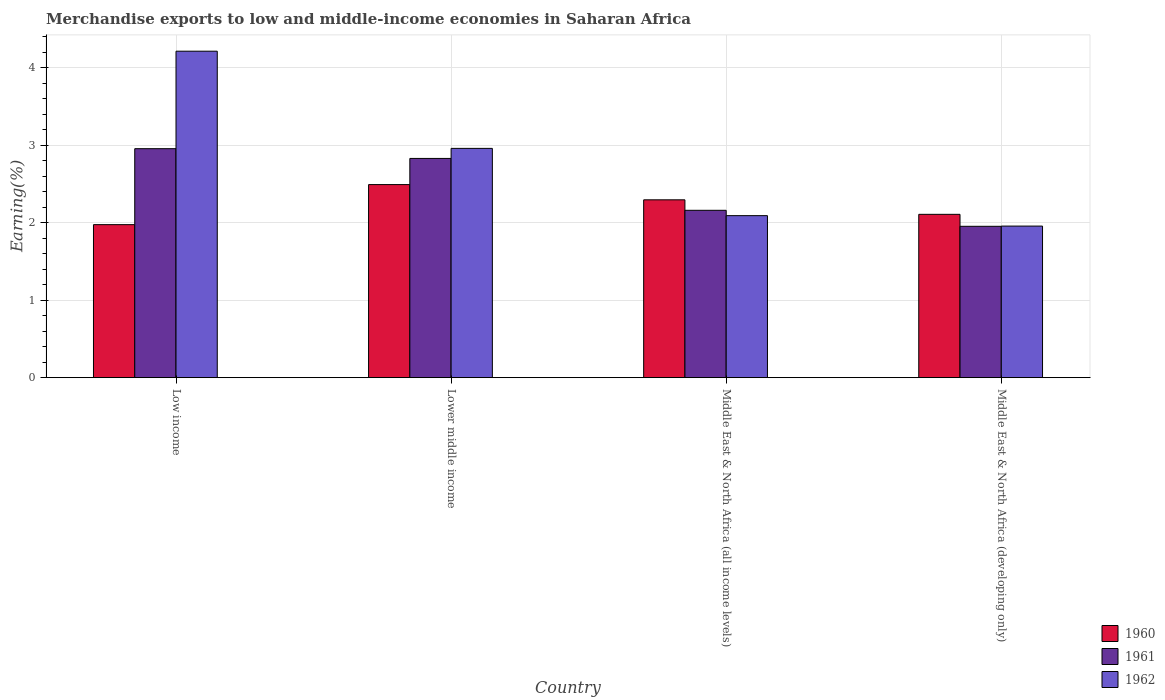How many different coloured bars are there?
Your answer should be very brief. 3. How many groups of bars are there?
Ensure brevity in your answer.  4. Are the number of bars on each tick of the X-axis equal?
Offer a terse response. Yes. What is the label of the 4th group of bars from the left?
Provide a succinct answer. Middle East & North Africa (developing only). What is the percentage of amount earned from merchandise exports in 1962 in Lower middle income?
Your answer should be compact. 2.96. Across all countries, what is the maximum percentage of amount earned from merchandise exports in 1962?
Your answer should be compact. 4.21. Across all countries, what is the minimum percentage of amount earned from merchandise exports in 1961?
Your answer should be compact. 1.95. In which country was the percentage of amount earned from merchandise exports in 1961 maximum?
Ensure brevity in your answer.  Low income. What is the total percentage of amount earned from merchandise exports in 1960 in the graph?
Provide a succinct answer. 8.87. What is the difference between the percentage of amount earned from merchandise exports in 1960 in Middle East & North Africa (all income levels) and that in Middle East & North Africa (developing only)?
Provide a succinct answer. 0.19. What is the difference between the percentage of amount earned from merchandise exports in 1961 in Low income and the percentage of amount earned from merchandise exports in 1962 in Middle East & North Africa (all income levels)?
Give a very brief answer. 0.86. What is the average percentage of amount earned from merchandise exports in 1960 per country?
Keep it short and to the point. 2.22. What is the difference between the percentage of amount earned from merchandise exports of/in 1960 and percentage of amount earned from merchandise exports of/in 1961 in Low income?
Keep it short and to the point. -0.98. What is the ratio of the percentage of amount earned from merchandise exports in 1962 in Lower middle income to that in Middle East & North Africa (all income levels)?
Offer a very short reply. 1.42. Is the difference between the percentage of amount earned from merchandise exports in 1960 in Lower middle income and Middle East & North Africa (all income levels) greater than the difference between the percentage of amount earned from merchandise exports in 1961 in Lower middle income and Middle East & North Africa (all income levels)?
Offer a very short reply. No. What is the difference between the highest and the second highest percentage of amount earned from merchandise exports in 1960?
Ensure brevity in your answer.  -0.38. What is the difference between the highest and the lowest percentage of amount earned from merchandise exports in 1962?
Make the answer very short. 2.26. Is the sum of the percentage of amount earned from merchandise exports in 1960 in Middle East & North Africa (all income levels) and Middle East & North Africa (developing only) greater than the maximum percentage of amount earned from merchandise exports in 1961 across all countries?
Your response must be concise. Yes. What does the 3rd bar from the left in Low income represents?
Provide a succinct answer. 1962. Are all the bars in the graph horizontal?
Your answer should be very brief. No. What is the difference between two consecutive major ticks on the Y-axis?
Offer a very short reply. 1. Are the values on the major ticks of Y-axis written in scientific E-notation?
Give a very brief answer. No. What is the title of the graph?
Your response must be concise. Merchandise exports to low and middle-income economies in Saharan Africa. Does "1995" appear as one of the legend labels in the graph?
Your response must be concise. No. What is the label or title of the X-axis?
Your answer should be very brief. Country. What is the label or title of the Y-axis?
Give a very brief answer. Earning(%). What is the Earning(%) of 1960 in Low income?
Offer a terse response. 1.97. What is the Earning(%) of 1961 in Low income?
Your answer should be very brief. 2.95. What is the Earning(%) in 1962 in Low income?
Give a very brief answer. 4.21. What is the Earning(%) of 1960 in Lower middle income?
Provide a succinct answer. 2.49. What is the Earning(%) in 1961 in Lower middle income?
Offer a terse response. 2.83. What is the Earning(%) in 1962 in Lower middle income?
Keep it short and to the point. 2.96. What is the Earning(%) of 1960 in Middle East & North Africa (all income levels)?
Your answer should be very brief. 2.29. What is the Earning(%) in 1961 in Middle East & North Africa (all income levels)?
Provide a succinct answer. 2.16. What is the Earning(%) in 1962 in Middle East & North Africa (all income levels)?
Offer a terse response. 2.09. What is the Earning(%) in 1960 in Middle East & North Africa (developing only)?
Keep it short and to the point. 2.11. What is the Earning(%) in 1961 in Middle East & North Africa (developing only)?
Make the answer very short. 1.95. What is the Earning(%) of 1962 in Middle East & North Africa (developing only)?
Keep it short and to the point. 1.96. Across all countries, what is the maximum Earning(%) of 1960?
Keep it short and to the point. 2.49. Across all countries, what is the maximum Earning(%) of 1961?
Your answer should be very brief. 2.95. Across all countries, what is the maximum Earning(%) of 1962?
Offer a terse response. 4.21. Across all countries, what is the minimum Earning(%) of 1960?
Ensure brevity in your answer.  1.97. Across all countries, what is the minimum Earning(%) of 1961?
Provide a succinct answer. 1.95. Across all countries, what is the minimum Earning(%) of 1962?
Offer a very short reply. 1.96. What is the total Earning(%) of 1960 in the graph?
Offer a terse response. 8.87. What is the total Earning(%) in 1961 in the graph?
Your response must be concise. 9.89. What is the total Earning(%) of 1962 in the graph?
Ensure brevity in your answer.  11.21. What is the difference between the Earning(%) in 1960 in Low income and that in Lower middle income?
Your answer should be compact. -0.52. What is the difference between the Earning(%) of 1961 in Low income and that in Lower middle income?
Make the answer very short. 0.13. What is the difference between the Earning(%) in 1962 in Low income and that in Lower middle income?
Your response must be concise. 1.25. What is the difference between the Earning(%) in 1960 in Low income and that in Middle East & North Africa (all income levels)?
Ensure brevity in your answer.  -0.32. What is the difference between the Earning(%) in 1961 in Low income and that in Middle East & North Africa (all income levels)?
Offer a terse response. 0.79. What is the difference between the Earning(%) in 1962 in Low income and that in Middle East & North Africa (all income levels)?
Ensure brevity in your answer.  2.12. What is the difference between the Earning(%) of 1960 in Low income and that in Middle East & North Africa (developing only)?
Make the answer very short. -0.13. What is the difference between the Earning(%) of 1961 in Low income and that in Middle East & North Africa (developing only)?
Keep it short and to the point. 1. What is the difference between the Earning(%) in 1962 in Low income and that in Middle East & North Africa (developing only)?
Provide a succinct answer. 2.26. What is the difference between the Earning(%) of 1960 in Lower middle income and that in Middle East & North Africa (all income levels)?
Provide a short and direct response. 0.2. What is the difference between the Earning(%) of 1961 in Lower middle income and that in Middle East & North Africa (all income levels)?
Your response must be concise. 0.67. What is the difference between the Earning(%) of 1962 in Lower middle income and that in Middle East & North Africa (all income levels)?
Ensure brevity in your answer.  0.87. What is the difference between the Earning(%) in 1960 in Lower middle income and that in Middle East & North Africa (developing only)?
Your answer should be compact. 0.38. What is the difference between the Earning(%) of 1961 in Lower middle income and that in Middle East & North Africa (developing only)?
Ensure brevity in your answer.  0.88. What is the difference between the Earning(%) of 1960 in Middle East & North Africa (all income levels) and that in Middle East & North Africa (developing only)?
Keep it short and to the point. 0.19. What is the difference between the Earning(%) of 1961 in Middle East & North Africa (all income levels) and that in Middle East & North Africa (developing only)?
Your answer should be very brief. 0.21. What is the difference between the Earning(%) in 1962 in Middle East & North Africa (all income levels) and that in Middle East & North Africa (developing only)?
Offer a terse response. 0.13. What is the difference between the Earning(%) in 1960 in Low income and the Earning(%) in 1961 in Lower middle income?
Ensure brevity in your answer.  -0.85. What is the difference between the Earning(%) in 1960 in Low income and the Earning(%) in 1962 in Lower middle income?
Provide a succinct answer. -0.98. What is the difference between the Earning(%) of 1961 in Low income and the Earning(%) of 1962 in Lower middle income?
Offer a very short reply. -0. What is the difference between the Earning(%) of 1960 in Low income and the Earning(%) of 1961 in Middle East & North Africa (all income levels)?
Give a very brief answer. -0.18. What is the difference between the Earning(%) of 1960 in Low income and the Earning(%) of 1962 in Middle East & North Africa (all income levels)?
Provide a succinct answer. -0.12. What is the difference between the Earning(%) in 1961 in Low income and the Earning(%) in 1962 in Middle East & North Africa (all income levels)?
Your response must be concise. 0.86. What is the difference between the Earning(%) of 1960 in Low income and the Earning(%) of 1961 in Middle East & North Africa (developing only)?
Ensure brevity in your answer.  0.02. What is the difference between the Earning(%) of 1960 in Low income and the Earning(%) of 1962 in Middle East & North Africa (developing only)?
Offer a very short reply. 0.02. What is the difference between the Earning(%) of 1960 in Lower middle income and the Earning(%) of 1961 in Middle East & North Africa (all income levels)?
Your answer should be very brief. 0.33. What is the difference between the Earning(%) of 1960 in Lower middle income and the Earning(%) of 1962 in Middle East & North Africa (all income levels)?
Give a very brief answer. 0.4. What is the difference between the Earning(%) in 1961 in Lower middle income and the Earning(%) in 1962 in Middle East & North Africa (all income levels)?
Offer a terse response. 0.74. What is the difference between the Earning(%) of 1960 in Lower middle income and the Earning(%) of 1961 in Middle East & North Africa (developing only)?
Provide a short and direct response. 0.54. What is the difference between the Earning(%) in 1960 in Lower middle income and the Earning(%) in 1962 in Middle East & North Africa (developing only)?
Ensure brevity in your answer.  0.54. What is the difference between the Earning(%) in 1961 in Lower middle income and the Earning(%) in 1962 in Middle East & North Africa (developing only)?
Make the answer very short. 0.87. What is the difference between the Earning(%) of 1960 in Middle East & North Africa (all income levels) and the Earning(%) of 1961 in Middle East & North Africa (developing only)?
Offer a terse response. 0.34. What is the difference between the Earning(%) of 1960 in Middle East & North Africa (all income levels) and the Earning(%) of 1962 in Middle East & North Africa (developing only)?
Give a very brief answer. 0.34. What is the difference between the Earning(%) in 1961 in Middle East & North Africa (all income levels) and the Earning(%) in 1962 in Middle East & North Africa (developing only)?
Provide a succinct answer. 0.2. What is the average Earning(%) in 1960 per country?
Your response must be concise. 2.22. What is the average Earning(%) in 1961 per country?
Make the answer very short. 2.47. What is the average Earning(%) in 1962 per country?
Provide a short and direct response. 2.8. What is the difference between the Earning(%) of 1960 and Earning(%) of 1961 in Low income?
Provide a short and direct response. -0.98. What is the difference between the Earning(%) in 1960 and Earning(%) in 1962 in Low income?
Offer a very short reply. -2.24. What is the difference between the Earning(%) of 1961 and Earning(%) of 1962 in Low income?
Provide a short and direct response. -1.26. What is the difference between the Earning(%) of 1960 and Earning(%) of 1961 in Lower middle income?
Keep it short and to the point. -0.34. What is the difference between the Earning(%) of 1960 and Earning(%) of 1962 in Lower middle income?
Your response must be concise. -0.47. What is the difference between the Earning(%) of 1961 and Earning(%) of 1962 in Lower middle income?
Provide a succinct answer. -0.13. What is the difference between the Earning(%) of 1960 and Earning(%) of 1961 in Middle East & North Africa (all income levels)?
Offer a very short reply. 0.14. What is the difference between the Earning(%) of 1960 and Earning(%) of 1962 in Middle East & North Africa (all income levels)?
Provide a succinct answer. 0.2. What is the difference between the Earning(%) in 1961 and Earning(%) in 1962 in Middle East & North Africa (all income levels)?
Provide a short and direct response. 0.07. What is the difference between the Earning(%) in 1960 and Earning(%) in 1961 in Middle East & North Africa (developing only)?
Your response must be concise. 0.15. What is the difference between the Earning(%) of 1960 and Earning(%) of 1962 in Middle East & North Africa (developing only)?
Keep it short and to the point. 0.15. What is the difference between the Earning(%) of 1961 and Earning(%) of 1962 in Middle East & North Africa (developing only)?
Your answer should be very brief. -0. What is the ratio of the Earning(%) in 1960 in Low income to that in Lower middle income?
Your response must be concise. 0.79. What is the ratio of the Earning(%) of 1961 in Low income to that in Lower middle income?
Provide a short and direct response. 1.04. What is the ratio of the Earning(%) of 1962 in Low income to that in Lower middle income?
Offer a very short reply. 1.42. What is the ratio of the Earning(%) of 1960 in Low income to that in Middle East & North Africa (all income levels)?
Keep it short and to the point. 0.86. What is the ratio of the Earning(%) of 1961 in Low income to that in Middle East & North Africa (all income levels)?
Ensure brevity in your answer.  1.37. What is the ratio of the Earning(%) in 1962 in Low income to that in Middle East & North Africa (all income levels)?
Your response must be concise. 2.02. What is the ratio of the Earning(%) of 1960 in Low income to that in Middle East & North Africa (developing only)?
Keep it short and to the point. 0.94. What is the ratio of the Earning(%) in 1961 in Low income to that in Middle East & North Africa (developing only)?
Your response must be concise. 1.51. What is the ratio of the Earning(%) in 1962 in Low income to that in Middle East & North Africa (developing only)?
Make the answer very short. 2.15. What is the ratio of the Earning(%) in 1960 in Lower middle income to that in Middle East & North Africa (all income levels)?
Offer a terse response. 1.09. What is the ratio of the Earning(%) of 1961 in Lower middle income to that in Middle East & North Africa (all income levels)?
Provide a succinct answer. 1.31. What is the ratio of the Earning(%) in 1962 in Lower middle income to that in Middle East & North Africa (all income levels)?
Provide a succinct answer. 1.42. What is the ratio of the Earning(%) in 1960 in Lower middle income to that in Middle East & North Africa (developing only)?
Offer a very short reply. 1.18. What is the ratio of the Earning(%) in 1961 in Lower middle income to that in Middle East & North Africa (developing only)?
Provide a short and direct response. 1.45. What is the ratio of the Earning(%) in 1962 in Lower middle income to that in Middle East & North Africa (developing only)?
Your answer should be compact. 1.51. What is the ratio of the Earning(%) of 1960 in Middle East & North Africa (all income levels) to that in Middle East & North Africa (developing only)?
Make the answer very short. 1.09. What is the ratio of the Earning(%) of 1961 in Middle East & North Africa (all income levels) to that in Middle East & North Africa (developing only)?
Your response must be concise. 1.11. What is the ratio of the Earning(%) in 1962 in Middle East & North Africa (all income levels) to that in Middle East & North Africa (developing only)?
Your answer should be very brief. 1.07. What is the difference between the highest and the second highest Earning(%) in 1960?
Give a very brief answer. 0.2. What is the difference between the highest and the second highest Earning(%) in 1961?
Give a very brief answer. 0.13. What is the difference between the highest and the second highest Earning(%) in 1962?
Give a very brief answer. 1.25. What is the difference between the highest and the lowest Earning(%) in 1960?
Offer a terse response. 0.52. What is the difference between the highest and the lowest Earning(%) of 1961?
Your answer should be very brief. 1. What is the difference between the highest and the lowest Earning(%) of 1962?
Offer a very short reply. 2.26. 